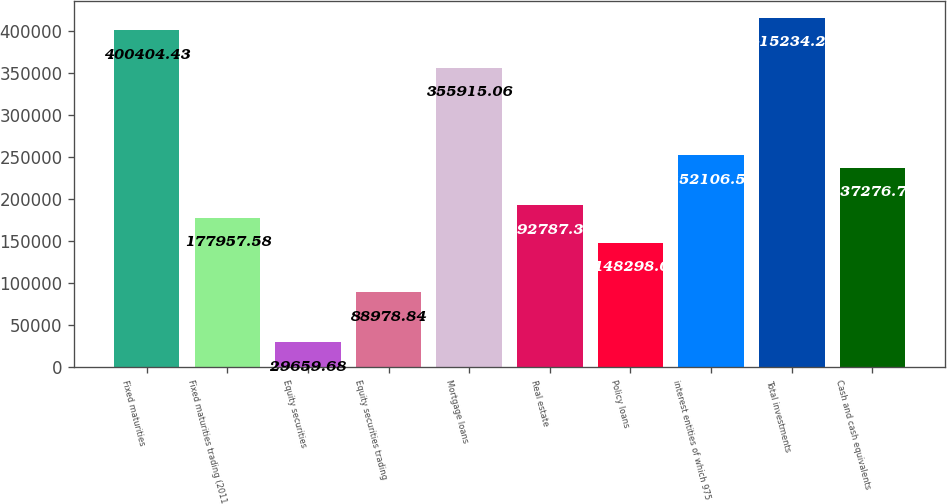<chart> <loc_0><loc_0><loc_500><loc_500><bar_chart><fcel>Fixed maturities<fcel>Fixed maturities trading (2011<fcel>Equity securities<fcel>Equity securities trading<fcel>Mortgage loans<fcel>Real estate<fcel>Policy loans<fcel>interest entities of which 975<fcel>Total investments<fcel>Cash and cash equivalents<nl><fcel>400404<fcel>177958<fcel>29659.7<fcel>88978.8<fcel>355915<fcel>192787<fcel>148298<fcel>252107<fcel>415234<fcel>237277<nl></chart> 